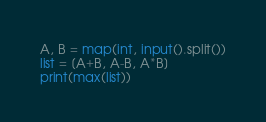<code> <loc_0><loc_0><loc_500><loc_500><_Python_>A, B = map(int, input().split())
list = [A+B, A-B, A*B]
print(max(list))</code> 